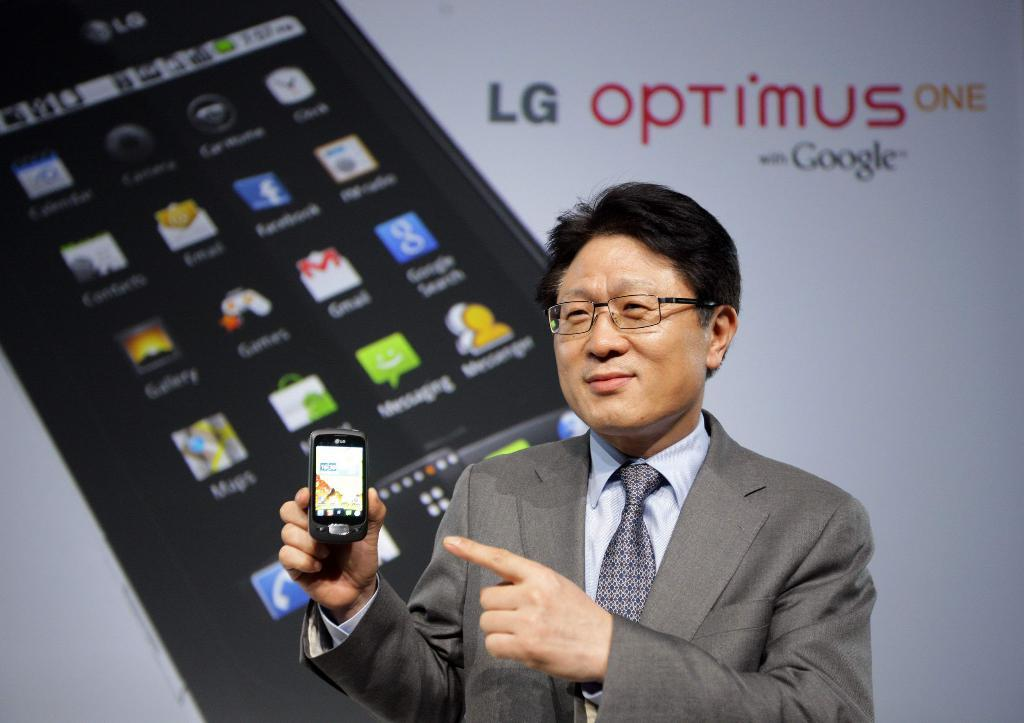<image>
Create a compact narrative representing the image presented. a man with an LG optimus phone in his hand 